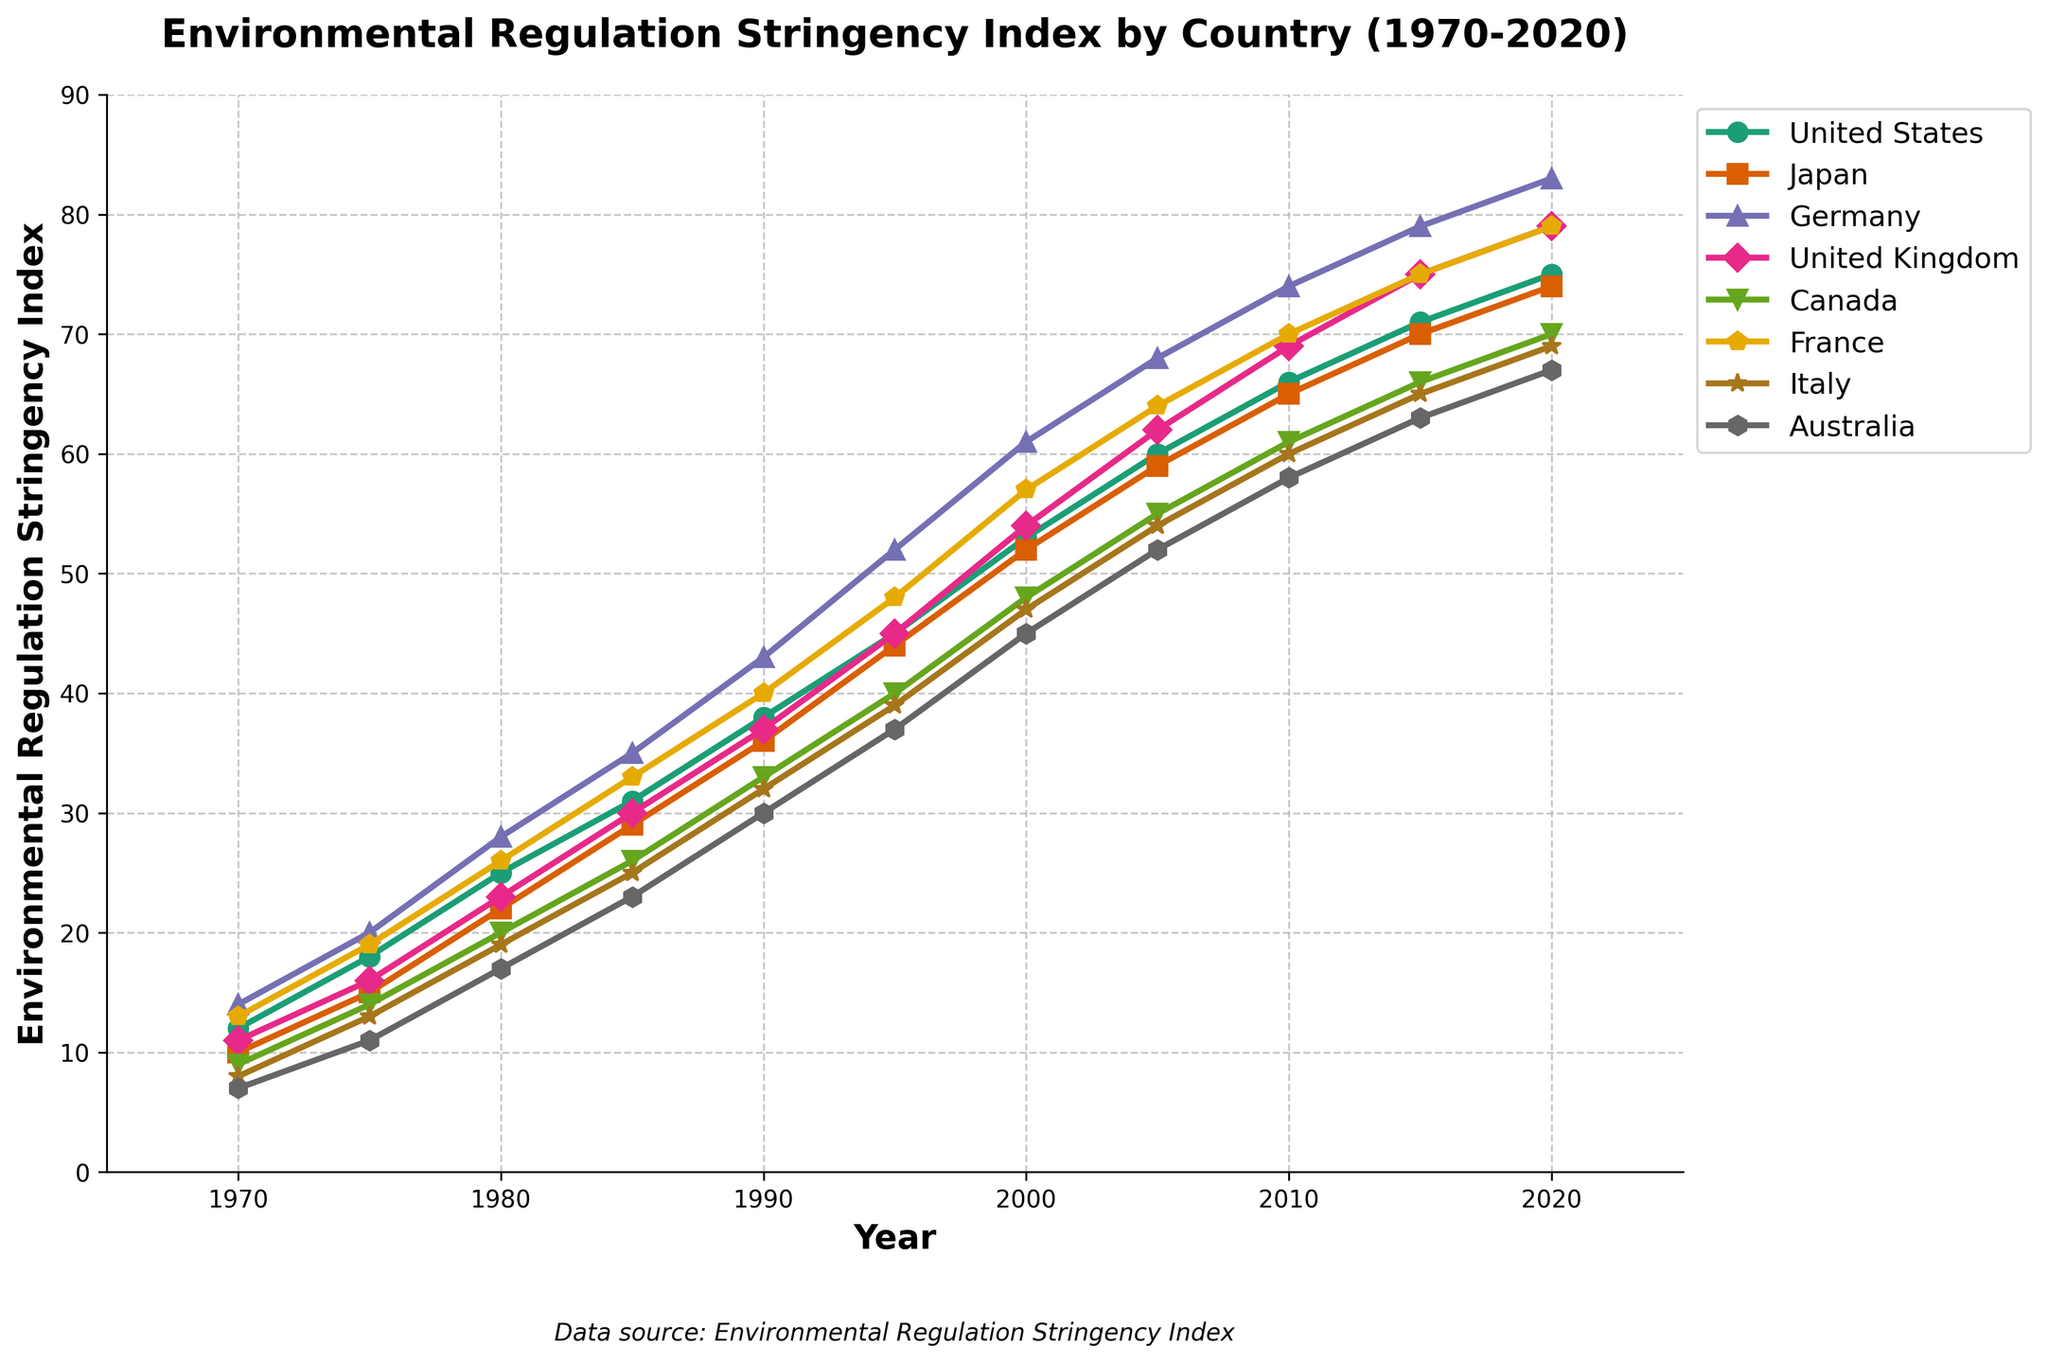Which country had the highest Environmental Regulation Stringency Index in 2020? To find the answer, locate the data points for 2020 for each country on the chart and identify the highest value.
Answer: Germany How much did the Environmental Regulation Stringency Index for the United States increase from 1970 to 2020? Identify the points for the United States in 1970 (12) and in 2020 (75), then subtract the 1970 value from the 2020 value: 75 - 12.
Answer: 63 Which countries had an Environmental Regulation Stringency Index of 45 in 2000? Locate the value of 45 on the index for the year 2000 and find the corresponding countries. Both the United Kingdom and Australia have a 45 value in 2000.
Answer: United Kingdom, Australia What is the average Environmental Regulation Stringency Index for France from 1970 to 2020? Sum up France's values (13 + 19 + 26 + 33 + 40 + 48 + 57 + 64 + 70 + 75 + 79) and divide by the number of data points (11): (13 + 19 + 26 + 33 + 40 + 48 + 57 + 64 + 70 + 75 + 79) / 11.
Answer: 47.27 Which country showed the smallest change in the Environmental Regulation Stringency Index from 1970 to 2020? Calculate the change for each country over the period by subtracting the 1970 value from the 2020 value and compare the results: (United States 63, Japan 64, Germany 69, United Kingdom 68, Canada 61, France 66, Italy 61, Australia 60).
Answer: Australia In which decade did Japan see its largest increase in the Environmental Regulation Stringency Index? Analyze the increments for Japan from decade to decade (1970-1980: 22-10=12, 1980-1990: 36-22=14, 1990-2000: 52-36=16, 2000-2010: 65-52=13, 2010-2020: 74-65=9) and identify the largest increase.
Answer: 1990-2000 What is the difference in the Environmental Regulation Stringency Index between Germany and Italy in 2015? Locate the values for Germany (79) and Italy (65) in 2015 and subtract the Italy value from the Germany value: 79 - 65.
Answer: 14 How does the Environmental Regulation Stringency Index for Canada compare to that of the United Kingdom in 2005? Find the values for Canada (55) and the United Kingdom (62) in 2005 and compare (Canada < United Kingdom).
Answer: Canada's index is lower than the UK's Which country had the most consistent year-over-year increase in the Environmental Regulation Stringency Index from 1970 to 2020? To identify the country, look at all countries' trends, and determine which one has a relatively straight and consistent upward line without significant fluctuations.
Answer: United States By how much did Italy's Environmental Regulation Stringency Index change between 1980 and 1990? Check Italy's values in 1980 (19) and 1990 (32), then subtract the 1980 value from the 1990 value: 32 - 19.
Answer: 13 